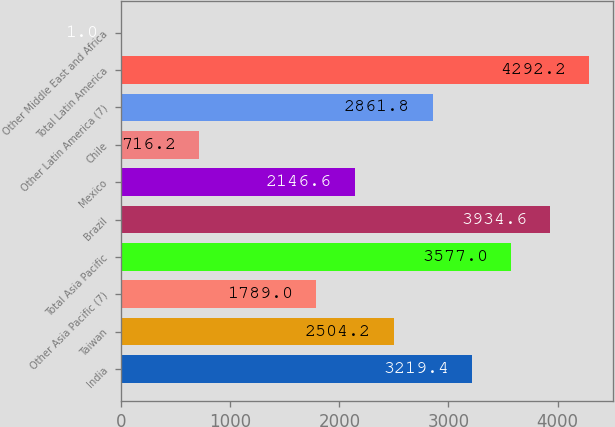<chart> <loc_0><loc_0><loc_500><loc_500><bar_chart><fcel>India<fcel>Taiwan<fcel>Other Asia Pacific (7)<fcel>Total Asia Pacific<fcel>Brazil<fcel>Mexico<fcel>Chile<fcel>Other Latin America (7)<fcel>Total Latin America<fcel>Other Middle East and Africa<nl><fcel>3219.4<fcel>2504.2<fcel>1789<fcel>3577<fcel>3934.6<fcel>2146.6<fcel>716.2<fcel>2861.8<fcel>4292.2<fcel>1<nl></chart> 